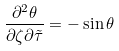Convert formula to latex. <formula><loc_0><loc_0><loc_500><loc_500>\frac { \partial ^ { 2 } \theta } { \partial \zeta \partial \tilde { \tau } } = - \sin { \theta }</formula> 